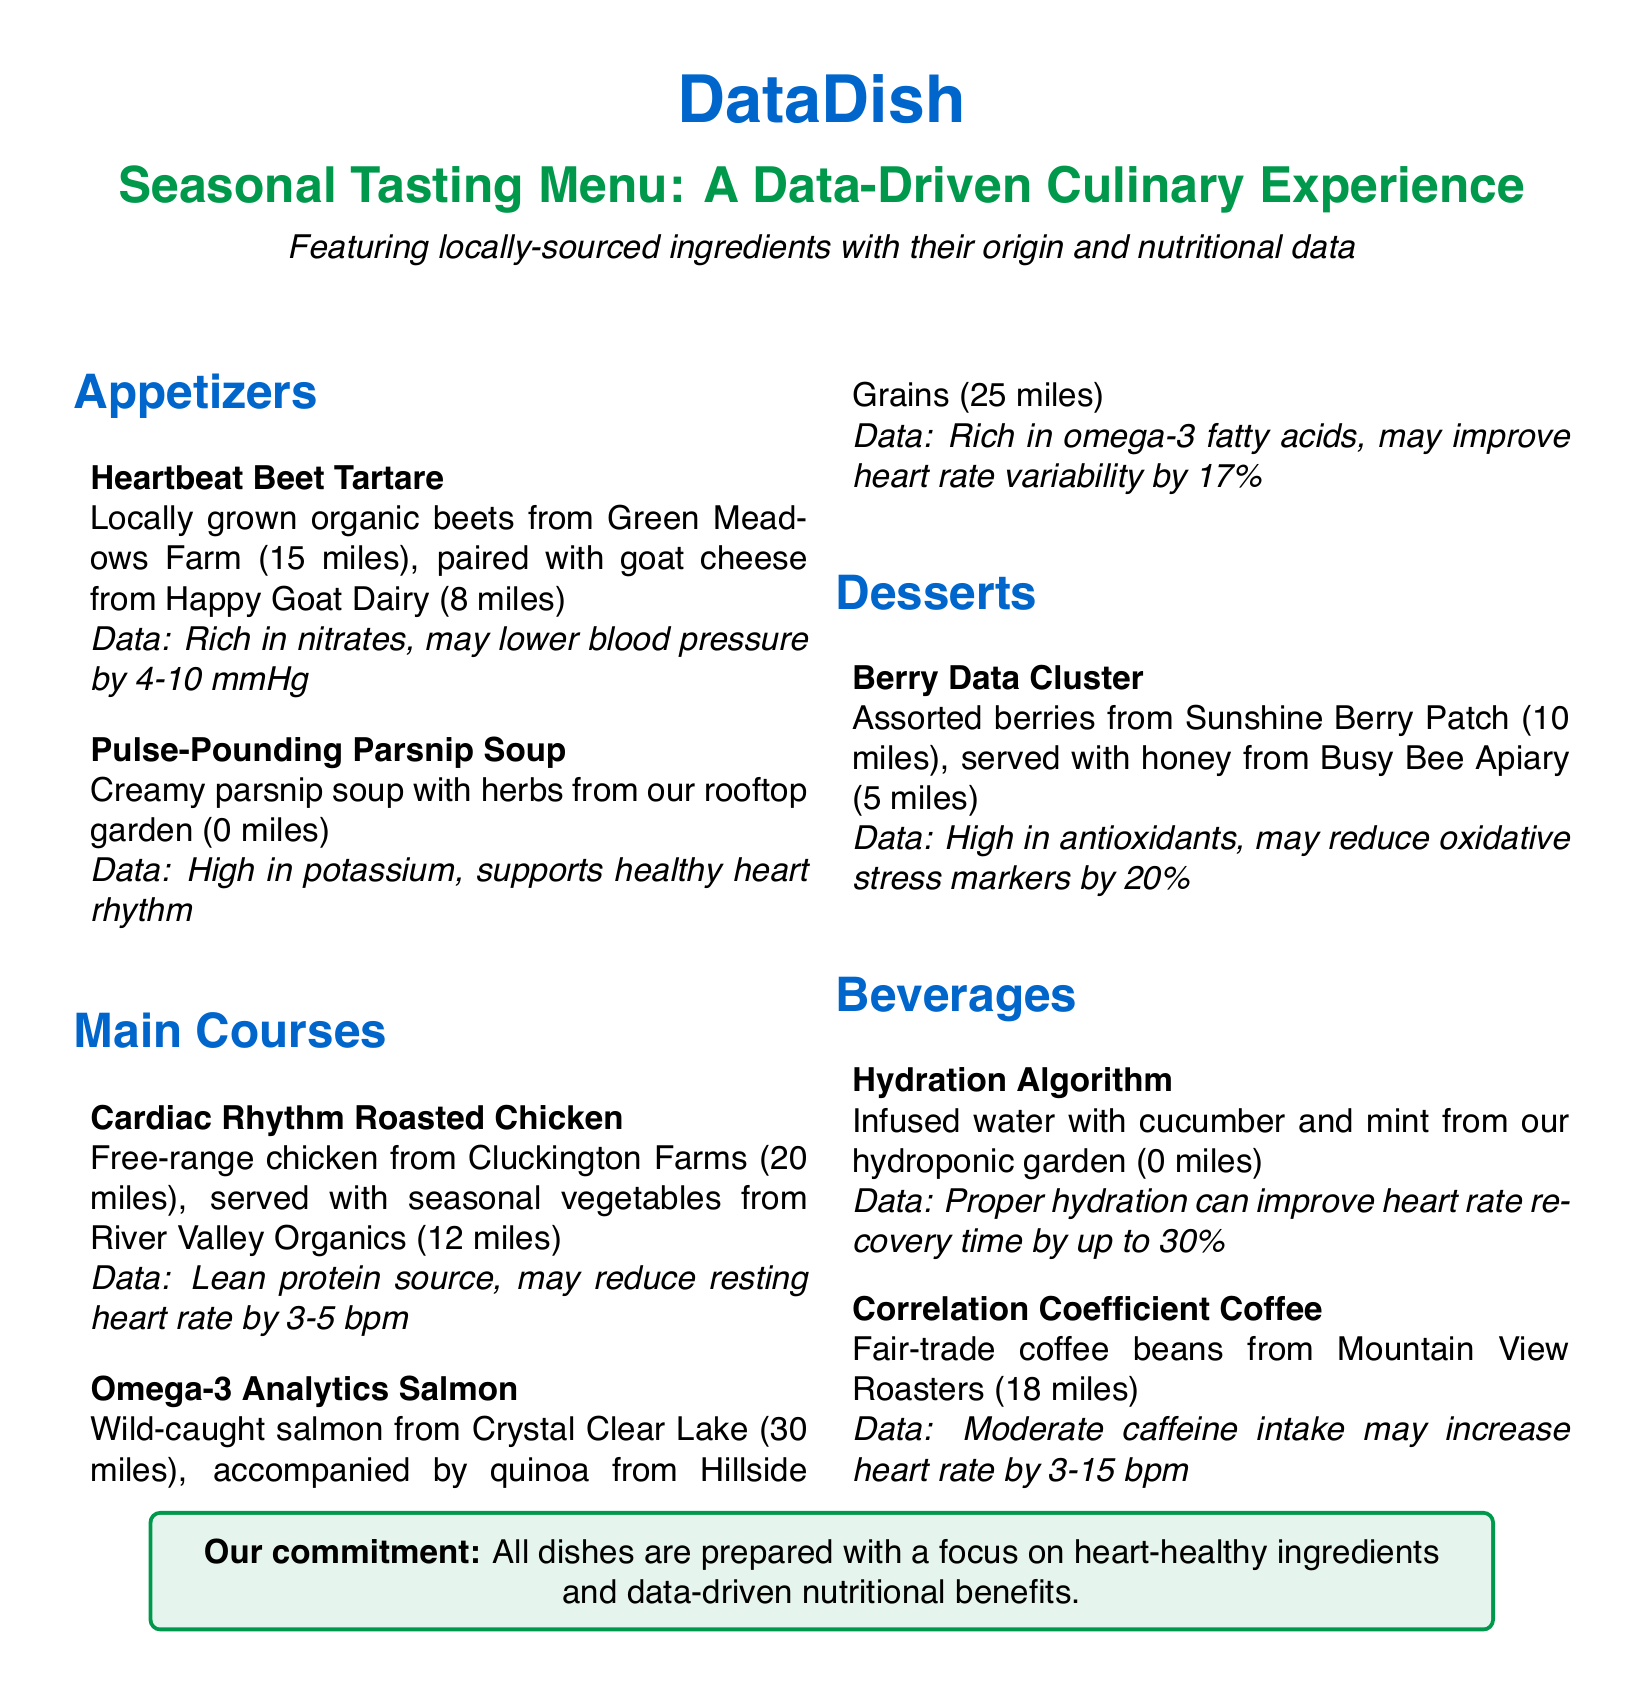What is the origin of the beets in the Heartbeat Beet Tartare? The beets are sourced from Green Meadows Farm, which is located 15 miles away.
Answer: Green Meadows Farm (15 miles) What ingredient is used in the Pulse-Pounding Parsnip Soup? The soup is made creamy with locally sourced parsnips and herbs from the rooftop garden, which is 0 miles away.
Answer: Herbs from our rooftop garden (0 miles) How far are Cluckington Farms from the restaurant? Cluckington Farms is where the free-range chicken is sourced, located 20 miles away.
Answer: 20 miles What type of salmon is used in the Omega-3 Analytics Salmon dish? The dish features wild-caught salmon, specifically from Crystal Clear Lake.
Answer: Wild-caught salmon How many miles away is Hillside Grains? Hillside Grains provides quinoa for the dish, and it is located 25 miles away from the restaurant.
Answer: 25 miles What is the data related to the Berry Data Cluster dessert? The dessert is high in antioxidants, which may reduce oxidative stress markers by 20 percent.
Answer: May reduce oxidative stress markers by 20% How does the Hydration Algorithm beverage contribute to health? The infused water can improve heart rate recovery time by up to 30 percent.
Answer: Improve heart rate recovery time by up to 30% What type of coffee beans are used in the Correlation Coefficient Coffee? The coffee is made from fair-trade coffee beans sourced from Mountain View Roasters.
Answer: Fair-trade coffee beans What is the main focus of all dishes in the menu? The main focus is on heart-healthy ingredients and data-driven nutritional benefits.
Answer: Heart-healthy ingredients and data-driven nutritional benefits 